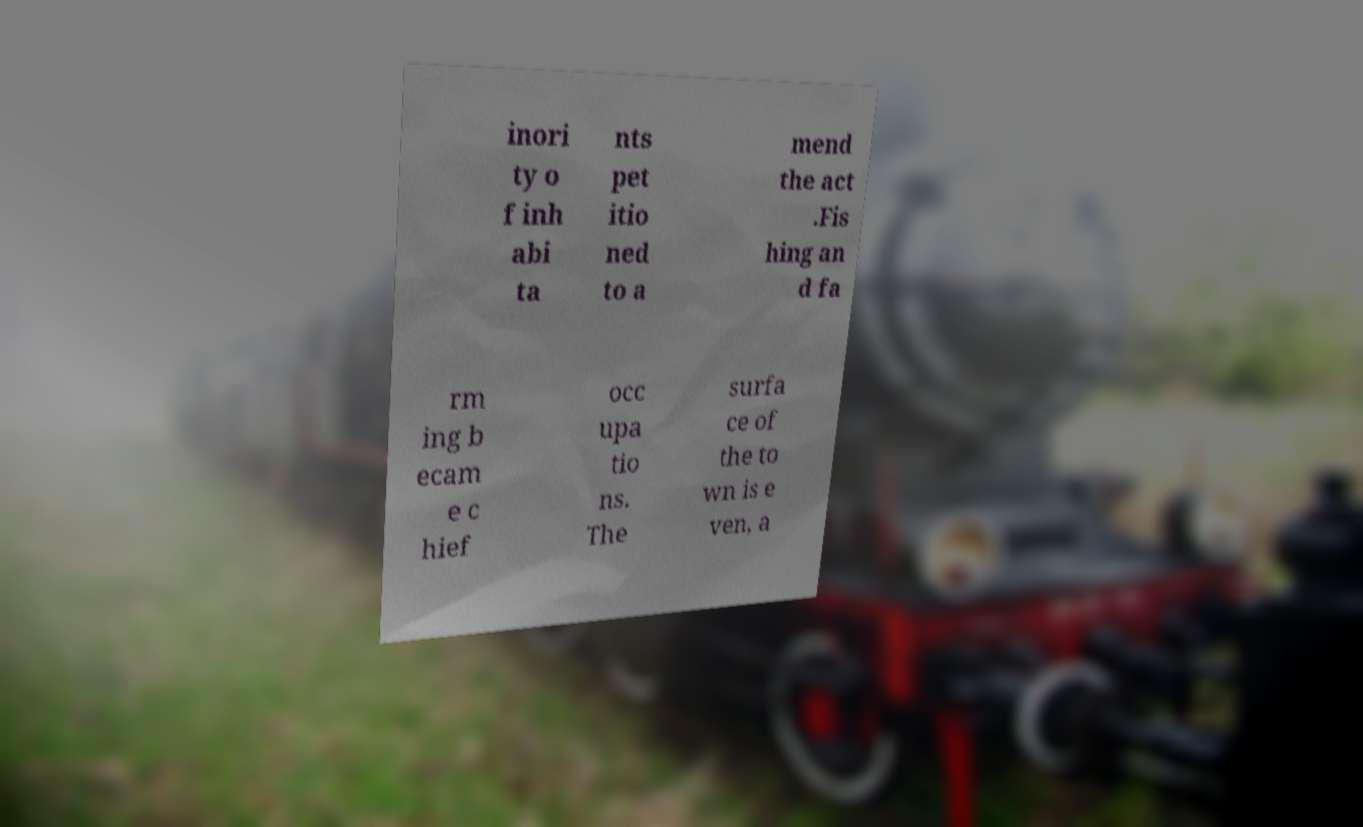For documentation purposes, I need the text within this image transcribed. Could you provide that? inori ty o f inh abi ta nts pet itio ned to a mend the act .Fis hing an d fa rm ing b ecam e c hief occ upa tio ns. The surfa ce of the to wn is e ven, a 